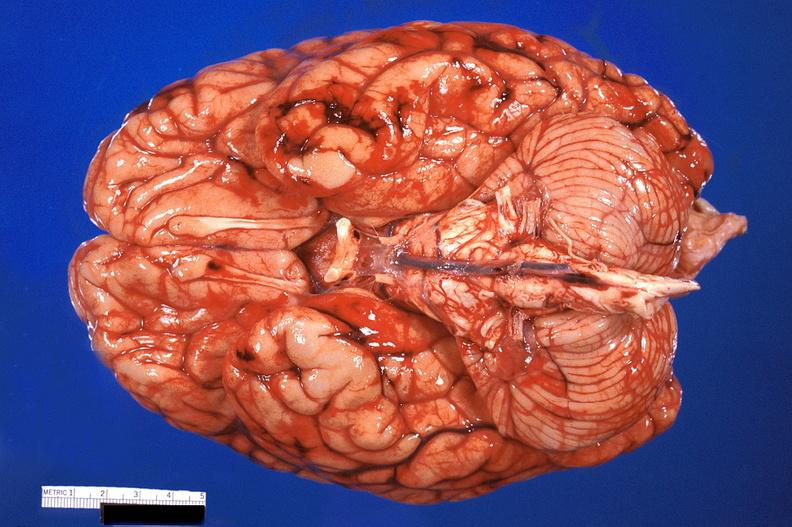does this image show brain, subarachanoid hemorrhage due to disseminated intravascular coagulation?
Answer the question using a single word or phrase. Yes 